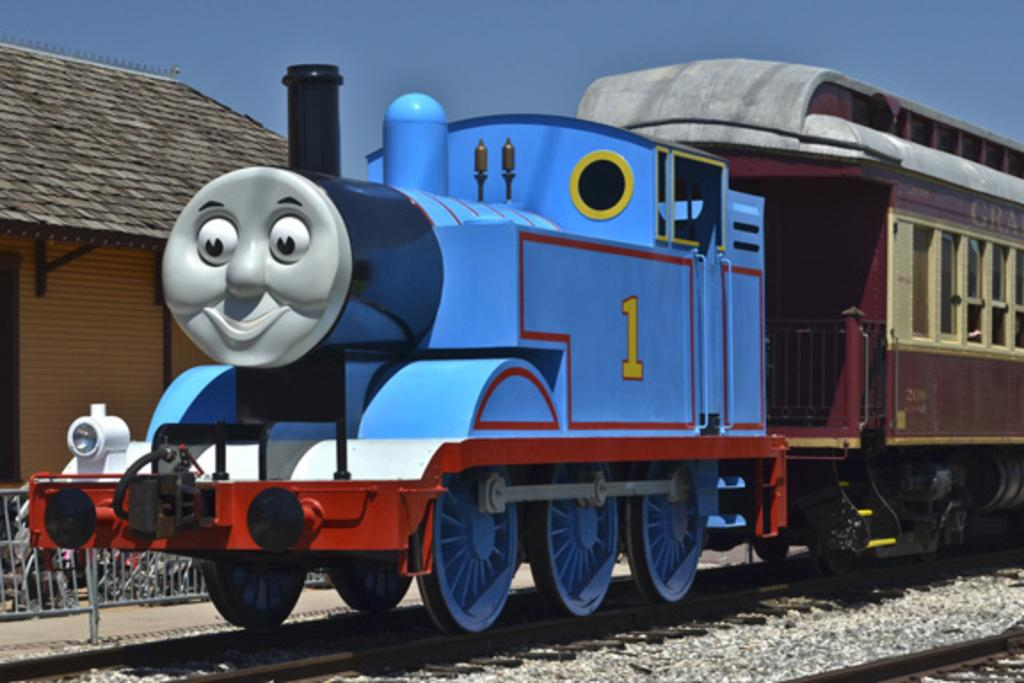Provide a one-sentence caption for the provided image. a large as life kiddie style train with a cartoon face and #1 on the side. 